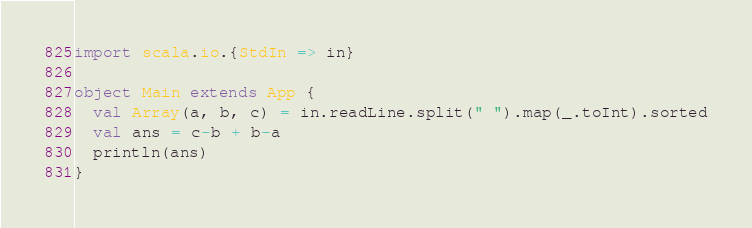<code> <loc_0><loc_0><loc_500><loc_500><_Scala_>import scala.io.{StdIn => in}

object Main extends App {
  val Array(a, b, c) = in.readLine.split(" ").map(_.toInt).sorted
  val ans = c-b + b-a
  println(ans)
}</code> 